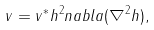Convert formula to latex. <formula><loc_0><loc_0><loc_500><loc_500>v = v ^ { * } h ^ { 2 } n a b l a ( \nabla ^ { 2 } h ) ,</formula> 